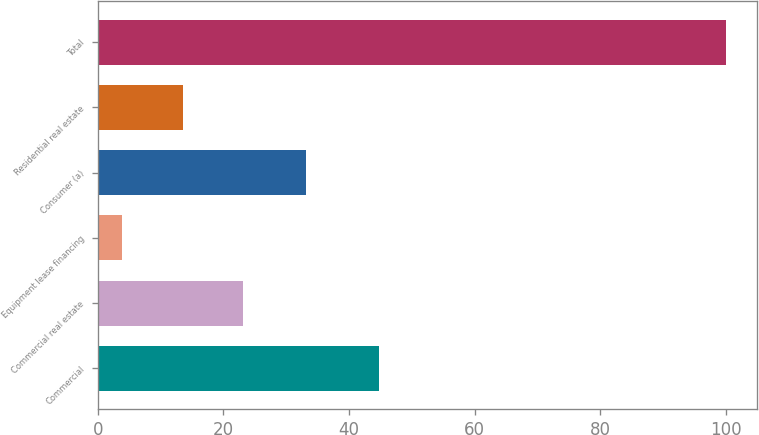Convert chart. <chart><loc_0><loc_0><loc_500><loc_500><bar_chart><fcel>Commercial<fcel>Commercial real estate<fcel>Equipment lease financing<fcel>Consumer (a)<fcel>Residential real estate<fcel>Total<nl><fcel>44.7<fcel>23.12<fcel>3.9<fcel>33.2<fcel>13.51<fcel>100<nl></chart> 